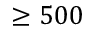<formula> <loc_0><loc_0><loc_500><loc_500>\geq 5 0 0</formula> 